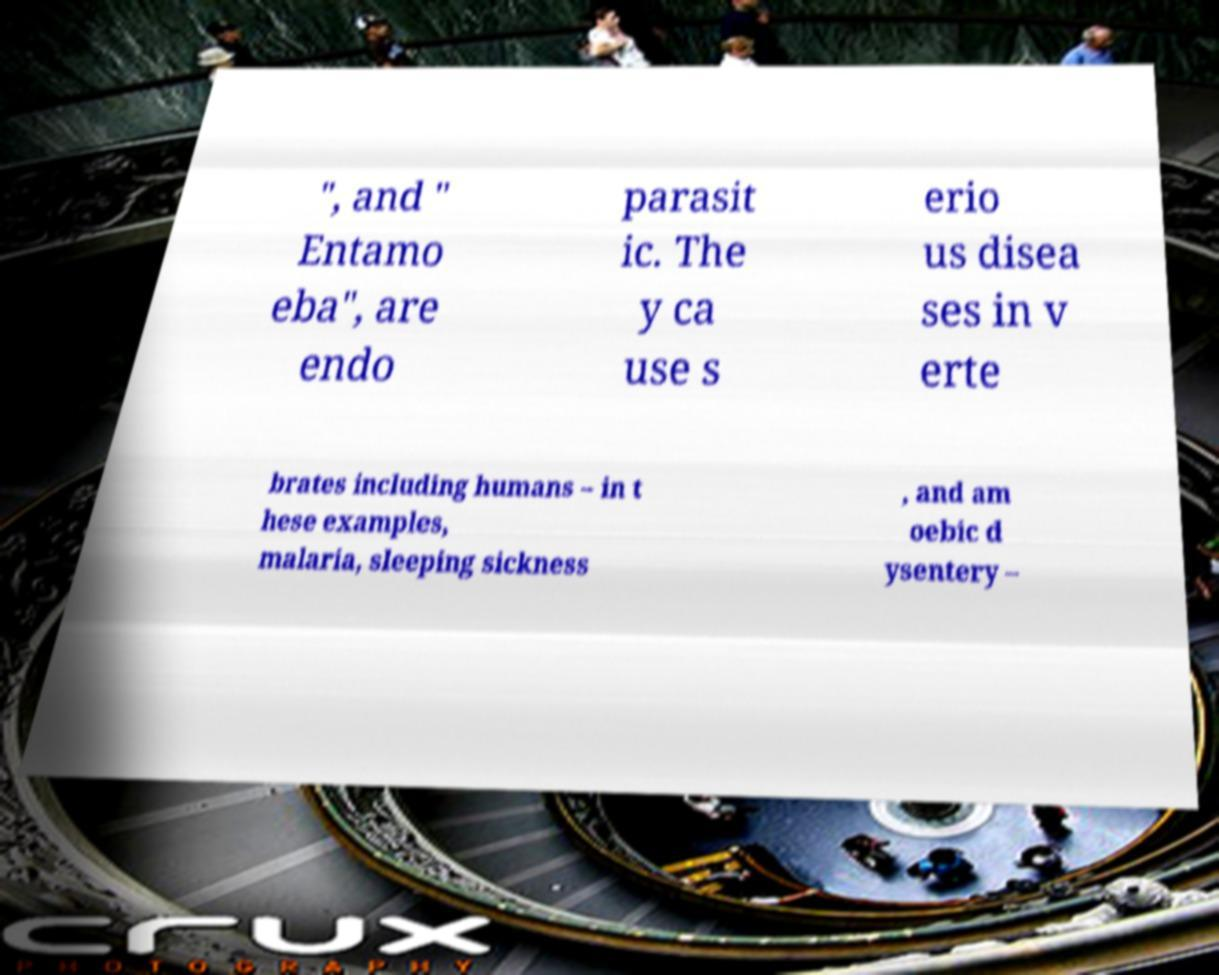There's text embedded in this image that I need extracted. Can you transcribe it verbatim? ", and " Entamo eba", are endo parasit ic. The y ca use s erio us disea ses in v erte brates including humans – in t hese examples, malaria, sleeping sickness , and am oebic d ysentery – 